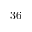<formula> <loc_0><loc_0><loc_500><loc_500>3 6</formula> 